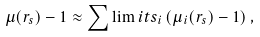Convert formula to latex. <formula><loc_0><loc_0><loc_500><loc_500>\mu ( { r } _ { s } ) - 1 \approx \sum \lim i t s _ { i } \left ( \mu _ { i } ( { r } _ { s } ) - 1 \right ) ,</formula> 